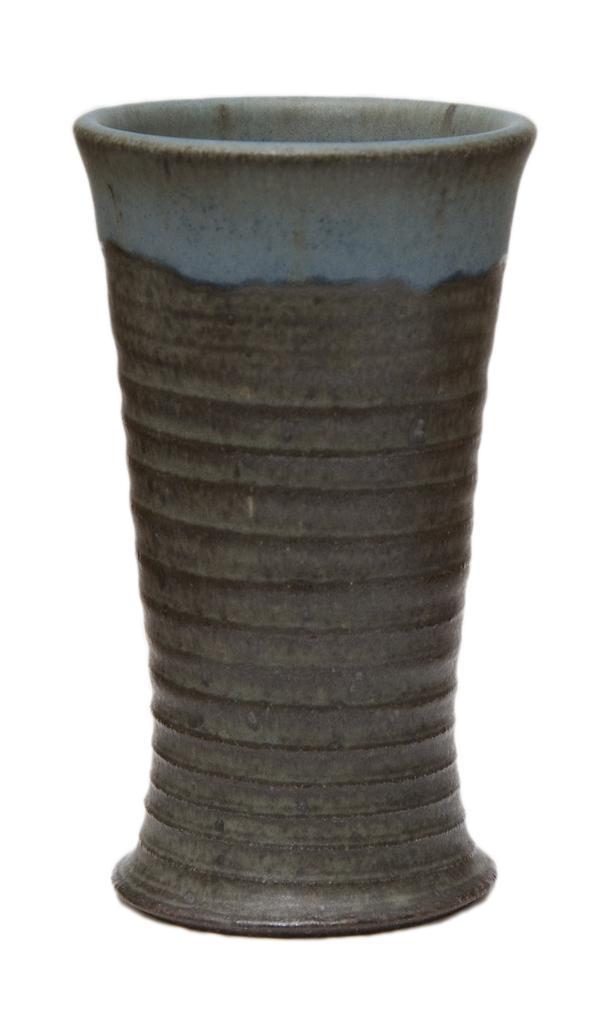Describe this image in one or two sentences. In this image i can see a clay pot and background is white. 